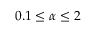<formula> <loc_0><loc_0><loc_500><loc_500>0 . 1 \leq \alpha \leq 2</formula> 